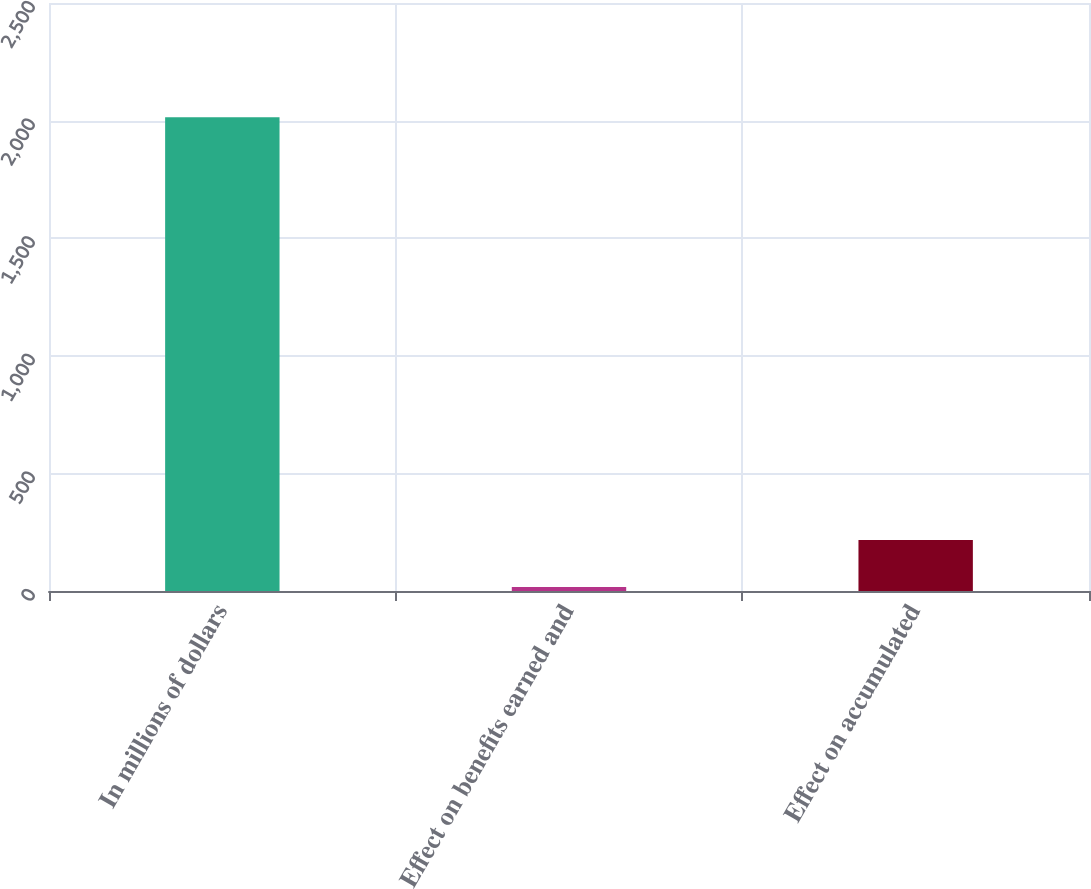<chart> <loc_0><loc_0><loc_500><loc_500><bar_chart><fcel>In millions of dollars<fcel>Effect on benefits earned and<fcel>Effect on accumulated<nl><fcel>2014<fcel>17<fcel>216.7<nl></chart> 